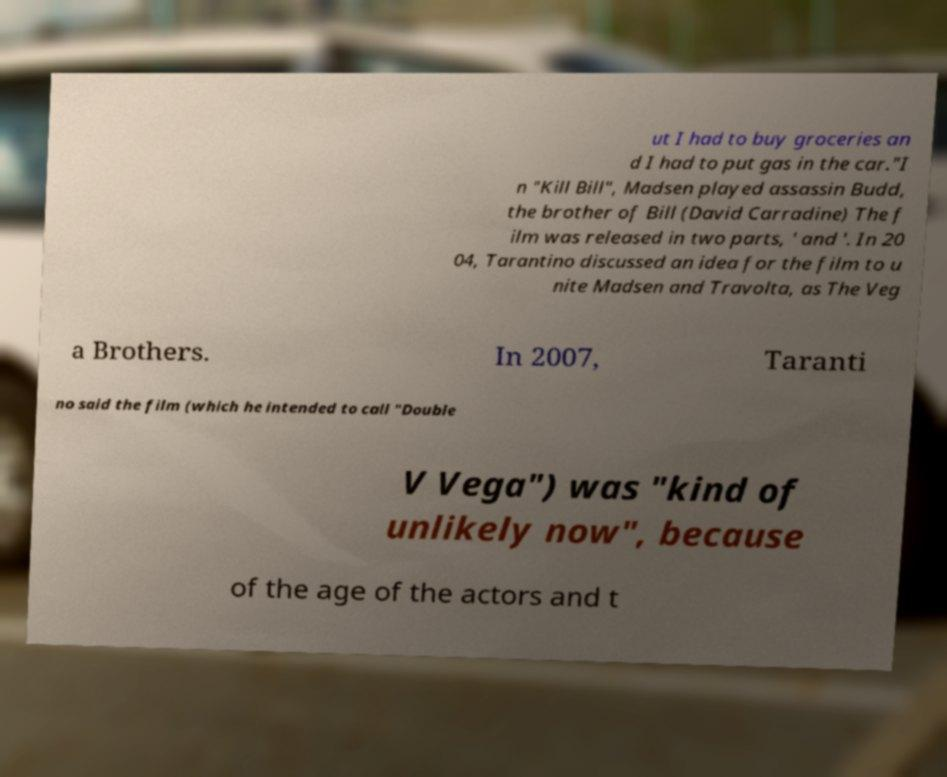Can you read and provide the text displayed in the image?This photo seems to have some interesting text. Can you extract and type it out for me? ut I had to buy groceries an d I had to put gas in the car."I n "Kill Bill", Madsen played assassin Budd, the brother of Bill (David Carradine) The f ilm was released in two parts, ' and '. In 20 04, Tarantino discussed an idea for the film to u nite Madsen and Travolta, as The Veg a Brothers. In 2007, Taranti no said the film (which he intended to call "Double V Vega") was "kind of unlikely now", because of the age of the actors and t 